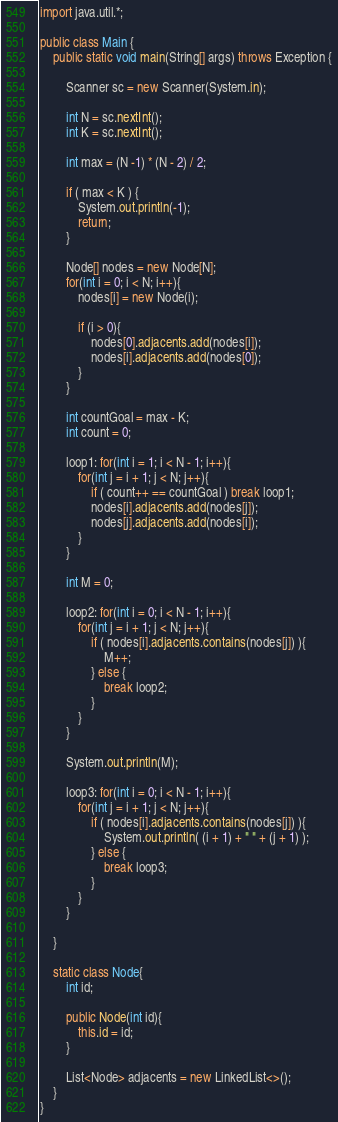<code> <loc_0><loc_0><loc_500><loc_500><_Java_>import java.util.*;

public class Main {
    public static void main(String[] args) throws Exception {
        
        Scanner sc = new Scanner(System.in);
        
        int N = sc.nextInt();
        int K = sc.nextInt();
        
        int max = (N -1) * (N - 2) / 2;
        
        if ( max < K ) {
            System.out.println(-1);
            return;
        }
        
        Node[] nodes = new Node[N];
        for(int i = 0; i < N; i++){
            nodes[i] = new Node(i);
            
            if (i > 0){
                nodes[0].adjacents.add(nodes[i]);
                nodes[i].adjacents.add(nodes[0]);
            }
        }
        
        int countGoal = max - K;
        int count = 0;

        loop1: for(int i = 1; i < N - 1; i++){
            for(int j = i + 1; j < N; j++){
                if ( count++ == countGoal ) break loop1;
                nodes[i].adjacents.add(nodes[j]);
                nodes[j].adjacents.add(nodes[i]);
            }
        }
        
        int M = 0;
        
        loop2: for(int i = 0; i < N - 1; i++){
            for(int j = i + 1; j < N; j++){
                if ( nodes[i].adjacents.contains(nodes[j]) ){
                    M++;
                } else {
                    break loop2;
                }
            }
        }
        
        System.out.println(M);
        
        loop3: for(int i = 0; i < N - 1; i++){
            for(int j = i + 1; j < N; j++){
                if ( nodes[i].adjacents.contains(nodes[j]) ){
                    System.out.println( (i + 1) + " " + (j + 1) );
                } else {
                    break loop3;
                }
            }
        }
        
    }
    
    static class Node{
        int id;
        
        public Node(int id){
            this.id = id;
        }
        
        List<Node> adjacents = new LinkedList<>();
    }
}
</code> 